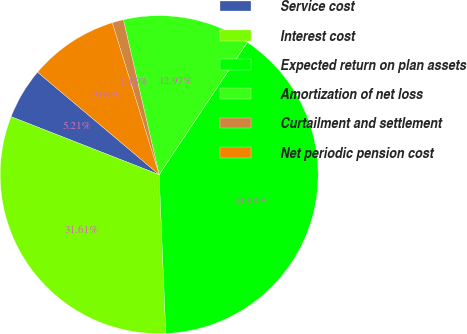<chart> <loc_0><loc_0><loc_500><loc_500><pie_chart><fcel>Service cost<fcel>Interest cost<fcel>Expected return on plan assets<fcel>Amortization of net loss<fcel>Curtailment and settlement<fcel>Net periodic pension cost<nl><fcel>5.21%<fcel>31.61%<fcel>39.98%<fcel>12.97%<fcel>1.15%<fcel>9.09%<nl></chart> 